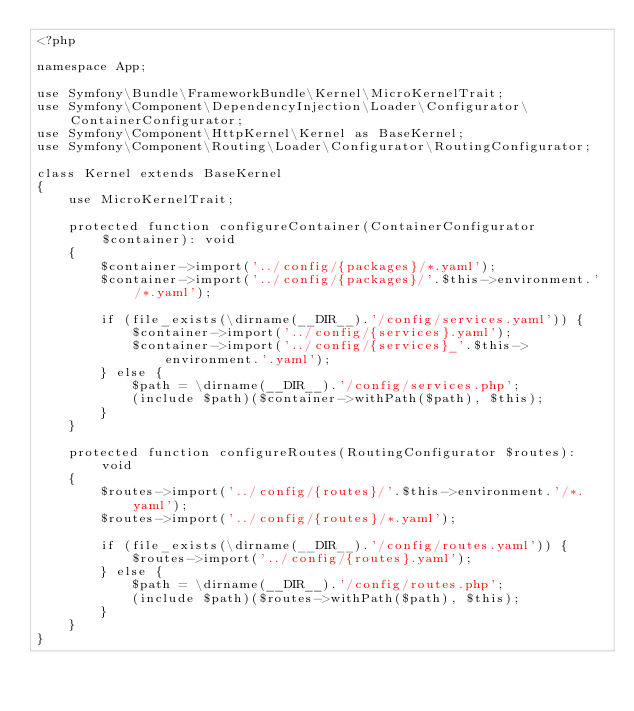Convert code to text. <code><loc_0><loc_0><loc_500><loc_500><_PHP_><?php

namespace App;

use Symfony\Bundle\FrameworkBundle\Kernel\MicroKernelTrait;
use Symfony\Component\DependencyInjection\Loader\Configurator\ContainerConfigurator;
use Symfony\Component\HttpKernel\Kernel as BaseKernel;
use Symfony\Component\Routing\Loader\Configurator\RoutingConfigurator;

class Kernel extends BaseKernel
{
    use MicroKernelTrait;

    protected function configureContainer(ContainerConfigurator $container): void
    {
        $container->import('../config/{packages}/*.yaml');
        $container->import('../config/{packages}/'.$this->environment.'/*.yaml');

        if (file_exists(\dirname(__DIR__).'/config/services.yaml')) {
            $container->import('../config/{services}.yaml');
            $container->import('../config/{services}_'.$this->environment.'.yaml');
        } else {
            $path = \dirname(__DIR__).'/config/services.php';
            (include $path)($container->withPath($path), $this);
        }
    }

    protected function configureRoutes(RoutingConfigurator $routes): void
    {
        $routes->import('../config/{routes}/'.$this->environment.'/*.yaml');
        $routes->import('../config/{routes}/*.yaml');

        if (file_exists(\dirname(__DIR__).'/config/routes.yaml')) {
            $routes->import('../config/{routes}.yaml');
        } else {
            $path = \dirname(__DIR__).'/config/routes.php';
            (include $path)($routes->withPath($path), $this);
        }
    }
}
</code> 